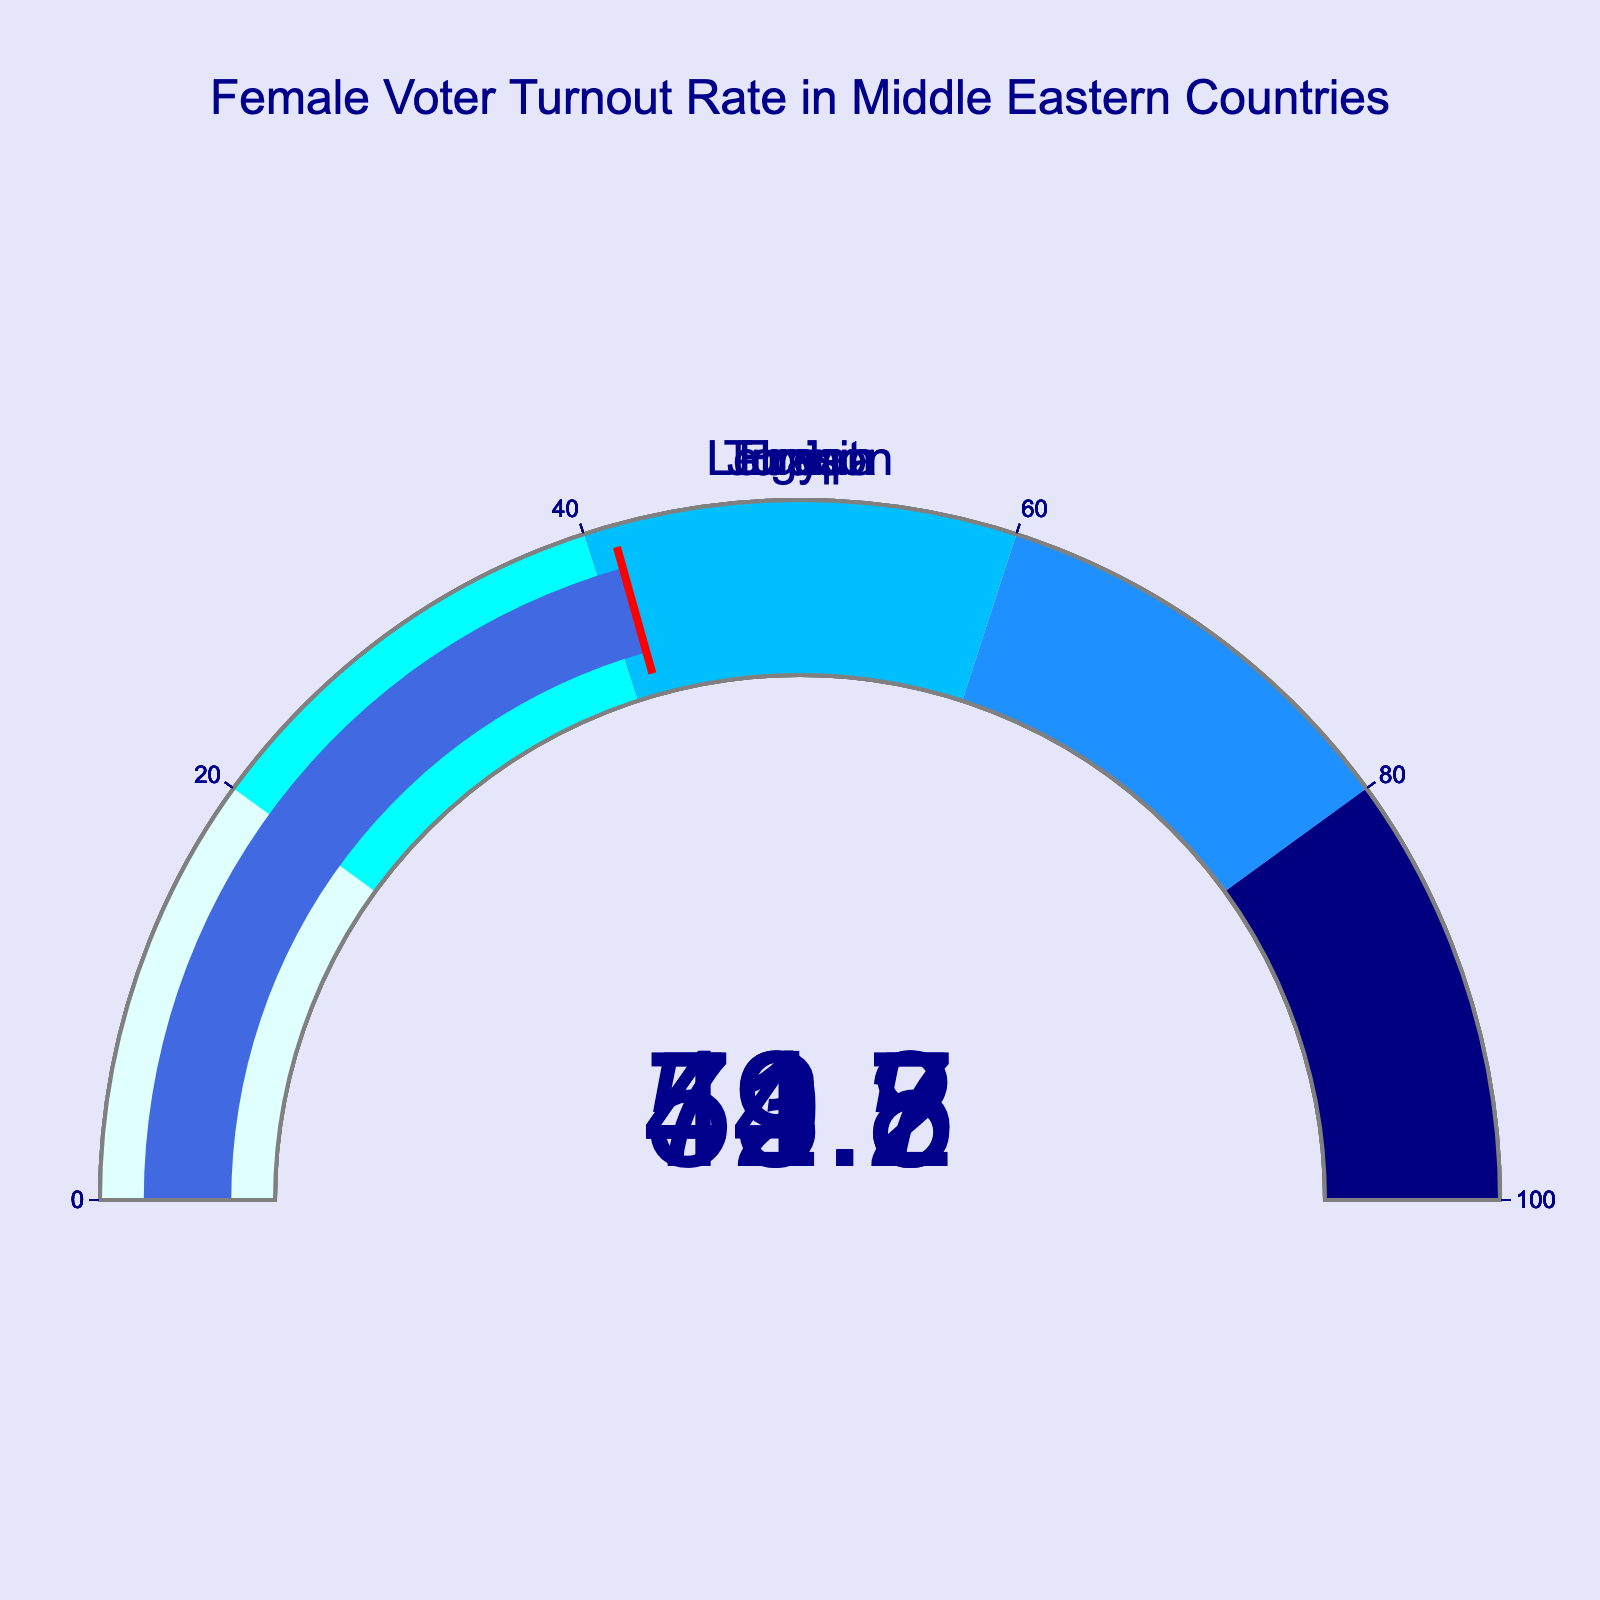What's the title of the figure? Look at the top of the figure to see the text displayed as the title.
Answer: Female Voter Turnout Rate in Middle Eastern Countries How many countries are represented in the figure? Count the number of separate gauges in the figure.
Answer: 5 What is the female voter turnout rate for Tunisia? Locate the gauge dedicated to Tunisia and read the number displayed.
Answer: 73.2% Which country has the highest female voter turnout rate? Compare the values shown on each gauge and identify the highest one.
Answer: Tunisia Which country has the lowest female voter turnout rate? Compare the values shown on each gauge and identify the lowest one.
Answer: Egypt What is the average female voter turnout rate among the countries shown? Sum all the female voter turnout rates and divide by the number of countries. (73.2 + 52.8 + 49.5 + 44.7 + 41.3) / 5 = 52.3
Answer: 52.3% By how much does the female voter turnout rate in Tunisia exceed that in Egypt? Subtract Egypt's rate from Tunisia's rate. 73.2 - 41.3 = 31.9
Answer: 31.9% Which country has a female voter turnout rate closest to 50%? Find the rate closest to 50% by comparing all the values.
Answer: Lebanon What color is used in the gauge for voter turnout rates between 60% and 80%? Check the steps in the color gradation on the gauges.
Answer: Dodger blue Are there any countries with a female voter turnout rate below 45%? Identify any gauges with a value below 45% and list the countries.
Answer: Iraq, Egypt 